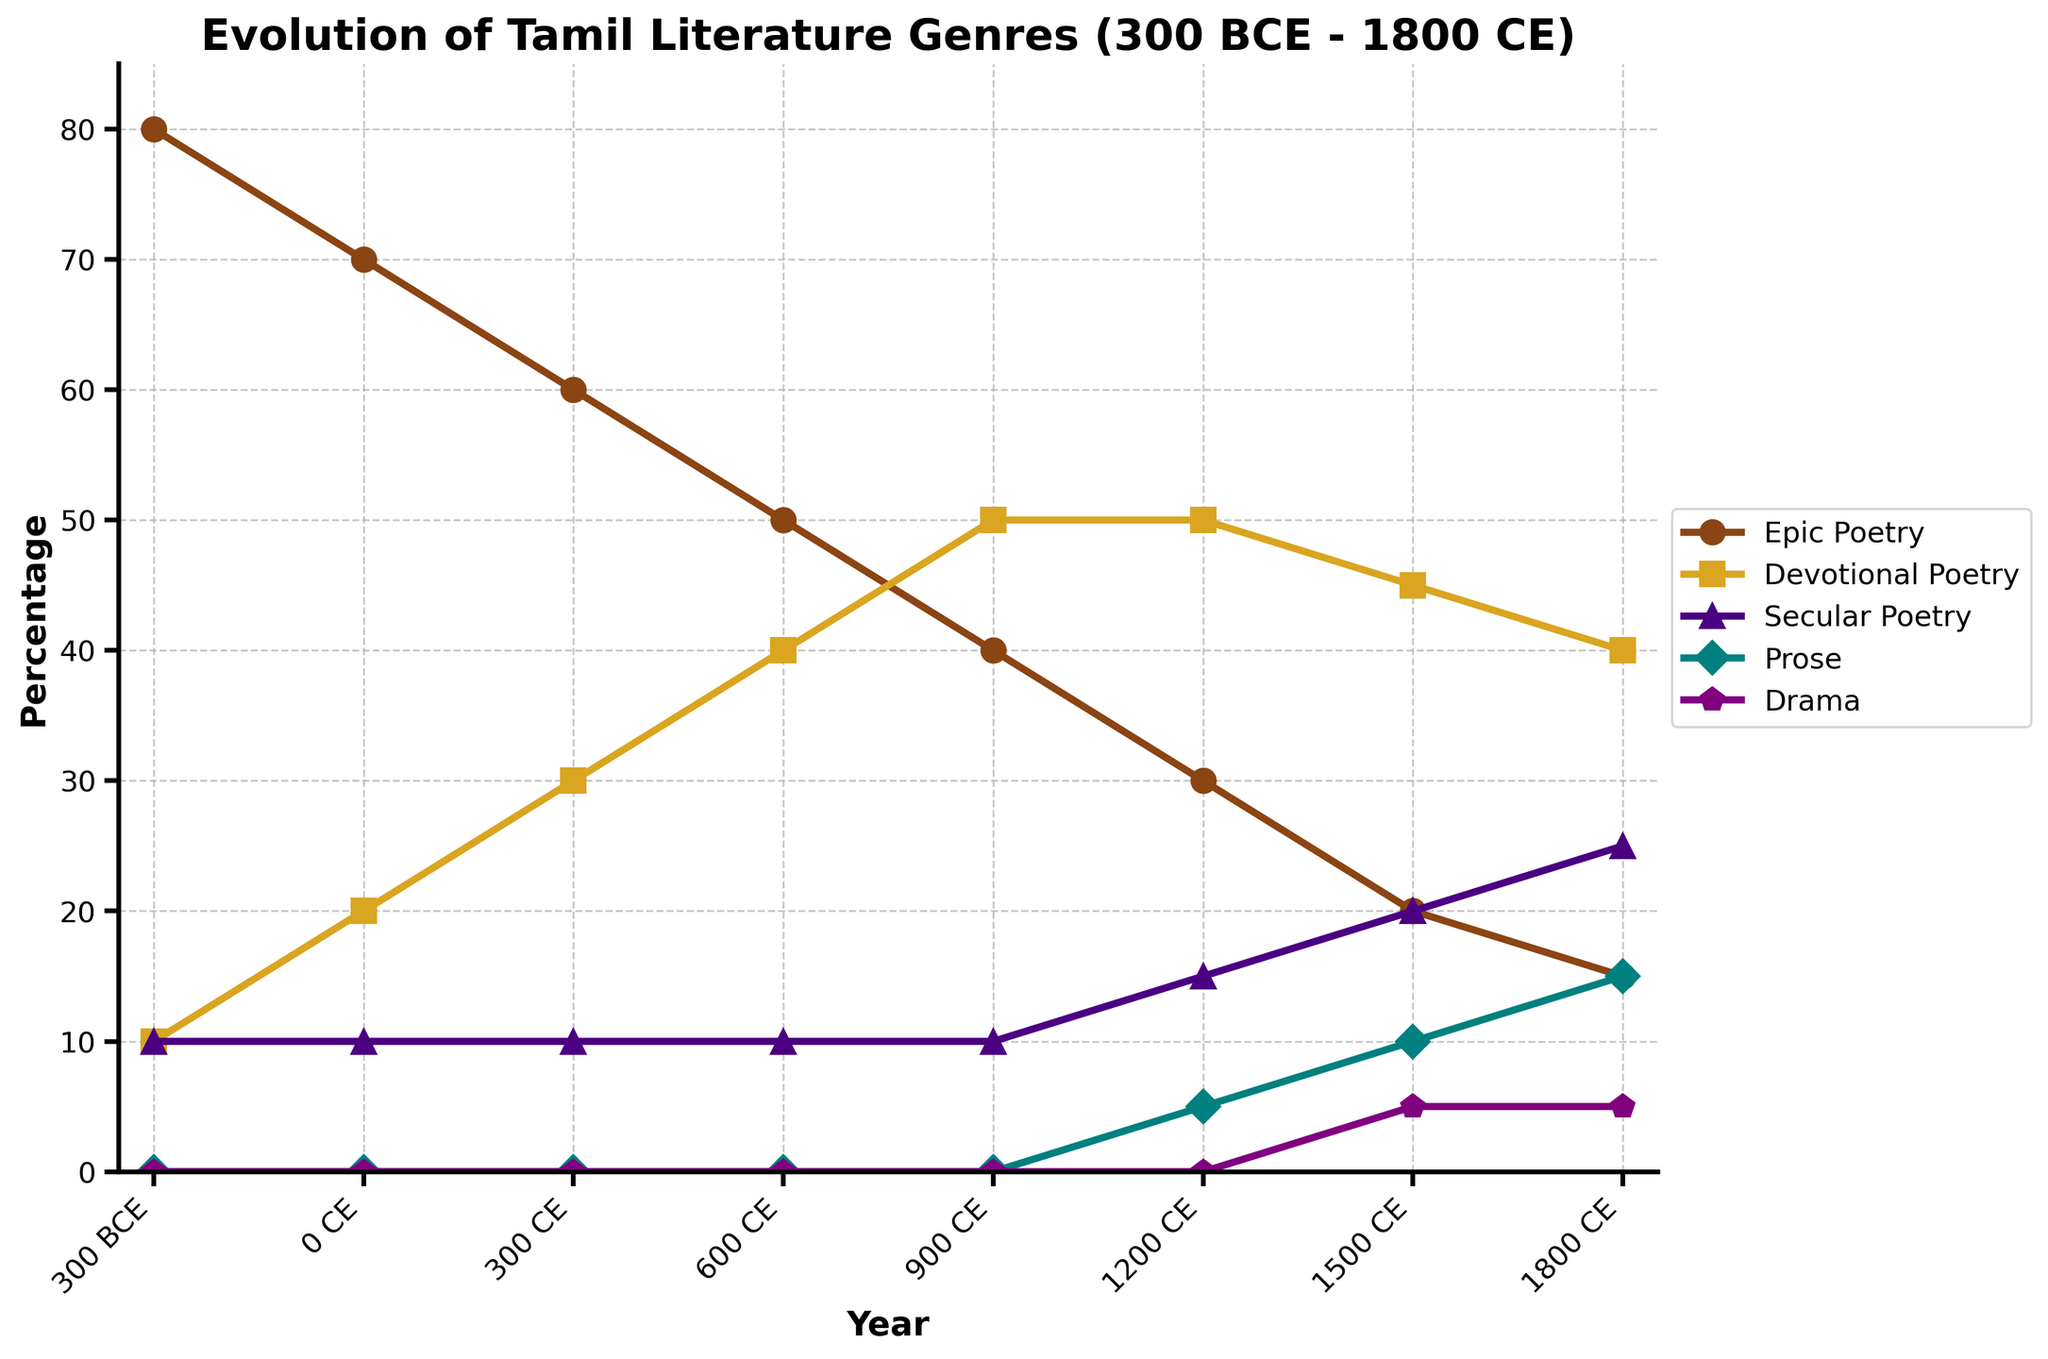What genre had the highest percentage around 300 CE? According to the figure, at 300 CE, the genre with the highest percentage is Devotional Poetry.
Answer: Devotional Poetry How did the percentage of Epic Poetry change from 300 BCE to 1800 CE? Epic Poetry starts at 80% in 300 BCE and decreases to 15% by 1800 CE.
Answer: Decreased Which two genres had the same percentage value around 1500 CE? Around 1500 CE, Secular Poetry and Drama both share the same percentage value of 5%.
Answer: Secular Poetry and Drama What is the percentage difference between Devotional Poetry and Secular Poetry in 900 CE? In 900 CE, Devotional Poetry is at 50%, while Secular Poetry is at 10%. The difference is calculated as 50 - 10.
Answer: 40% What genre has seen the most consistent increase from 300 BCE to 1800 CE? By examining the figure, we see Prose starts at 0% in 300 BCE and steadily increases to 15% by 1800 CE, showing a consistent rise.
Answer: Prose Which genre was dominant in 0 CE, and what was its percentage? In the year 0 CE, Epic Poetry was the dominant genre at 70%.
Answer: Epic Poetry, 70% By how much did the percentage of Devotional Poetry increase from 0 CE to 600 CE? At 0 CE, Devotional Poetry was at 20%, and by 600 CE, it increased to 40%. The increase is calculated as 40 - 20.
Answer: 20% Between 300 CE and 1500 CE, which genre decreased the most in percentage? By comparing the percentage changes from 300 CE to 1500 CE, Epic Poetry decreased from 60% to 20%, making it the genre with the largest decrease.
Answer: Epic Poetry Which genre had the smallest change in its percentage from 0 CE to 300 CE? Referring to the figure, Secular Poetry maintains a constant 10% from 0 CE to 300 CE, showing the smallest change.
Answer: Secular Poetry What genre appeared to have experienced the most fluctuation between 300 BCE and 1800 CE? By reviewing the figure, Epic Poetry shows a large range of decrease from 80% at 300 BCE to 15% at 1800 CE, indicating the most fluctuation.
Answer: Epic Poetry 